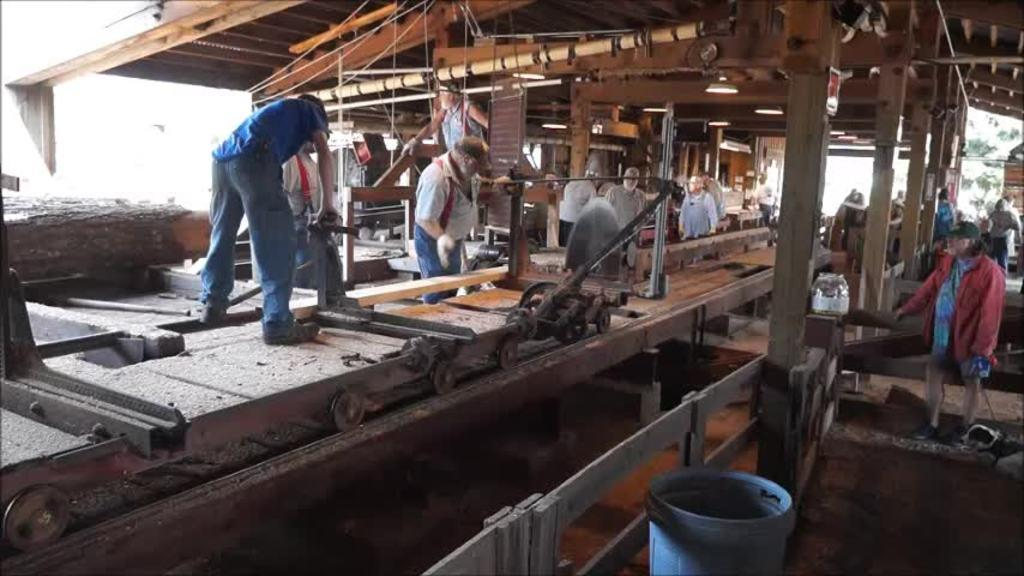What are the people in the image doing? The people in the image are working. What type of material is used for the objects in the image? The objects in the image are made of wood, including wooden pillars. What color is the blue object in the image? There is a blue color object in the image, but the specific shade or hue is not mentioned. Can you describe any other objects present in the image? There are other objects present in the image, but their details are not provided. Where is the baby playing with a dime in the image? There is no baby or dime present in the image; it features people working and wooden objects. 